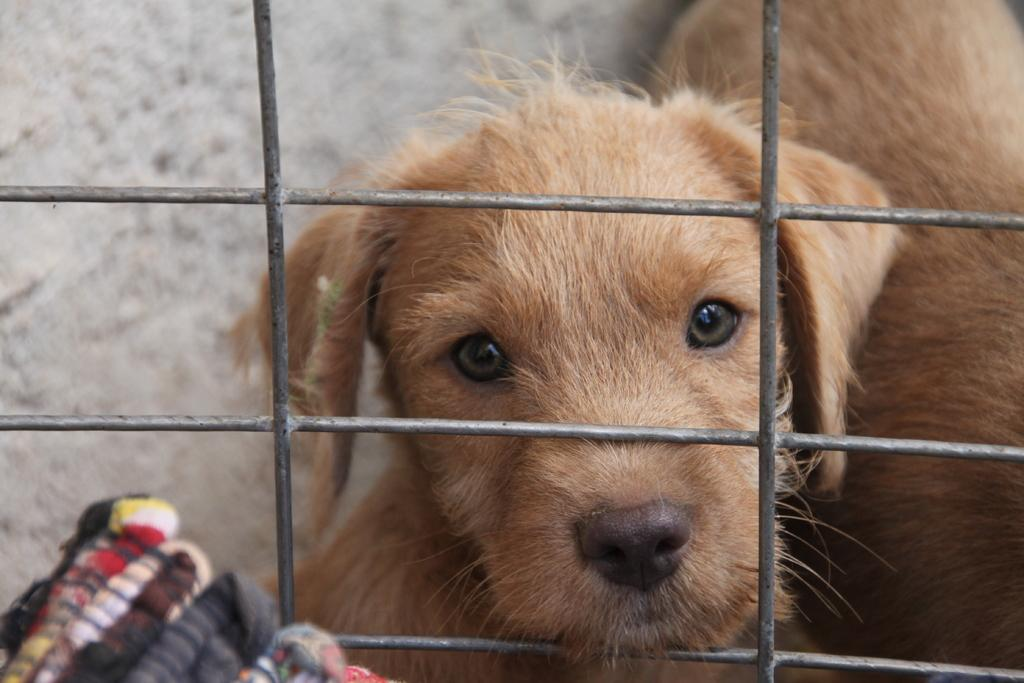What type of animal is in the image? There is a dog in the image. What color is the dog? The dog is brown in color. What is the dog's current location in the image? The dog is in a cage. How many apples are hanging from the dog's cage in the image? There are no apples present in the image, and therefore no such objects can be observed. 